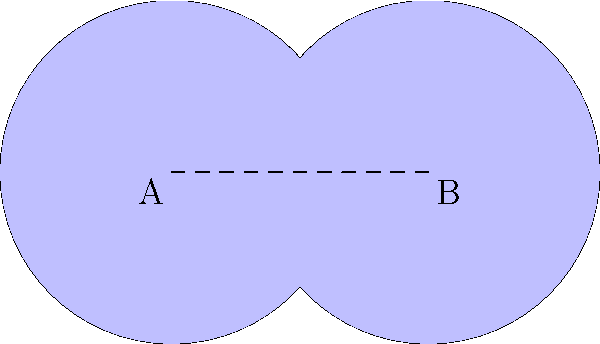In Toledo's historical district, two circular parks represent different eras: Park A symbolizes the industrial boom of the 1900s, while Park B represents the modern tech era. If each park has a radius of 100 meters and their centers are 150 meters apart, what is the area of the overlapping region where these historical eras merge? (Use $\pi \approx 3.14$) Let's approach this step-by-step:

1) First, we need to find the central angle of the sector formed in each circle by the intersection. We can do this using the cosine formula:

   $\cos(\theta/2) = \frac{d}{2r}$, where $d$ is the distance between centers and $r$ is the radius.

2) $\cos(\theta/2) = \frac{150}{2(100)} = 0.75$

3) $\theta/2 = \arccos(0.75) \approx 0.7227$ radians

4) $\theta \approx 1.4454$ radians

5) The area of each sector is: $A_{sector} = \frac{1}{2}r^2\theta = \frac{1}{2}(100^2)(1.4454) = 7,227$ sq meters

6) The area of the triangle formed by the circle centers and the intersection points is:
   $A_{triangle} = \frac{1}{2}(100)(100\sin(1.4454)) = 4,551$ sq meters

7) The area of the lens-shaped overlap is:
   $A_{overlap} = 2(A_{sector} - A_{triangle}) = 2(7,227 - 4,551) = 5,352$ sq meters

Therefore, the area of the overlapping region is approximately 5,352 square meters.
Answer: 5,352 square meters 